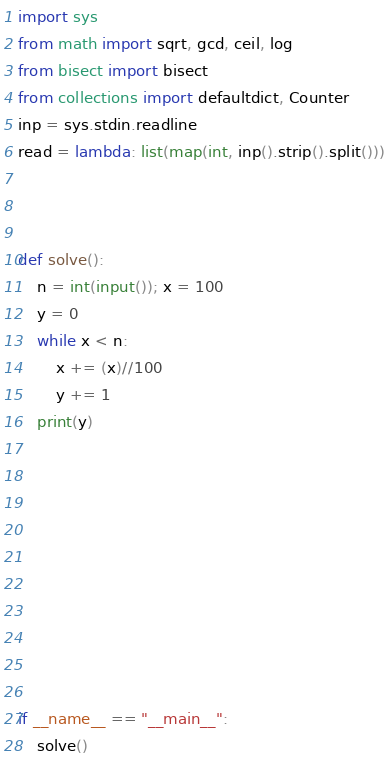Convert code to text. <code><loc_0><loc_0><loc_500><loc_500><_Python_>import sys
from math import sqrt, gcd, ceil, log
from bisect import bisect
from collections import defaultdict, Counter
inp = sys.stdin.readline
read = lambda: list(map(int, inp().strip().split()))



def solve():
	n = int(input()); x = 100
	y = 0
	while x < n:
		x += (x)//100
		y += 1
	print(y)


	





		

if __name__ == "__main__":
	solve()</code> 